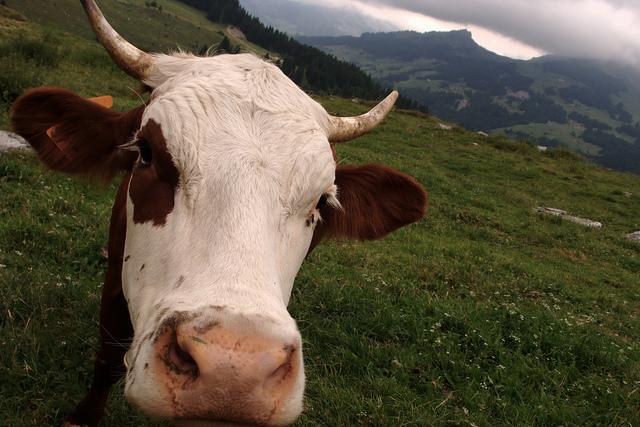Is the cow drinking?
Be succinct. No. What animal is this?
Concise answer only. Cow. How many cows have brown markings?
Short answer required. 1. Is it sunny?
Give a very brief answer. No. What color is the cow?
Short answer required. Brown and white. 